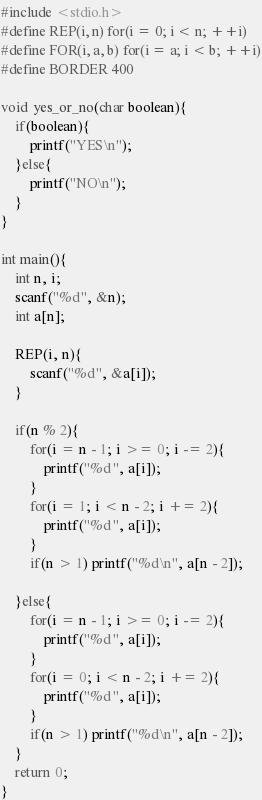Convert code to text. <code><loc_0><loc_0><loc_500><loc_500><_C_>#include <stdio.h>
#define REP(i, n) for(i = 0; i < n; ++i)
#define FOR(i, a, b) for(i = a; i < b; ++i)
#define BORDER 400

void yes_or_no(char boolean){
    if(boolean){
        printf("YES\n");
    }else{
        printf("NO\n");
    }
}

int main(){
    int n, i;
    scanf("%d", &n);
    int a[n];

    REP(i, n){
        scanf("%d", &a[i]);
    }

    if(n % 2){
        for(i = n - 1; i >= 0; i -= 2){
            printf("%d ", a[i]);
        }
        for(i = 1; i < n - 2; i += 2){
            printf("%d ", a[i]);
        }
        if(n > 1) printf("%d\n", a[n - 2]);

    }else{
        for(i = n - 1; i >= 0; i -= 2){
            printf("%d ", a[i]);
        }
        for(i = 0; i < n - 2; i += 2){
            printf("%d ", a[i]);
        }
        if(n > 1) printf("%d\n", a[n - 2]);
    }
    return 0;
}</code> 